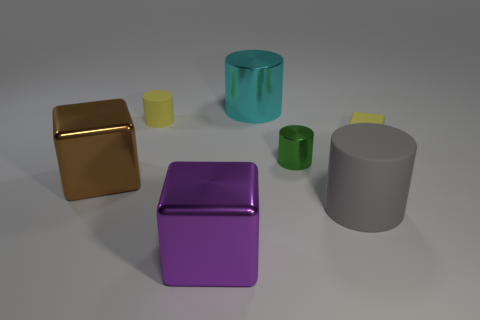Subtract all tiny rubber cylinders. How many cylinders are left? 3 Add 2 tiny cyan balls. How many objects exist? 9 Subtract all purple cubes. How many cubes are left? 2 Subtract all cylinders. How many objects are left? 3 Subtract 1 cylinders. How many cylinders are left? 3 Subtract all big yellow shiny cubes. Subtract all tiny blocks. How many objects are left? 6 Add 6 tiny yellow matte blocks. How many tiny yellow matte blocks are left? 7 Add 1 tiny yellow matte blocks. How many tiny yellow matte blocks exist? 2 Subtract 1 yellow cylinders. How many objects are left? 6 Subtract all red cylinders. Subtract all gray balls. How many cylinders are left? 4 